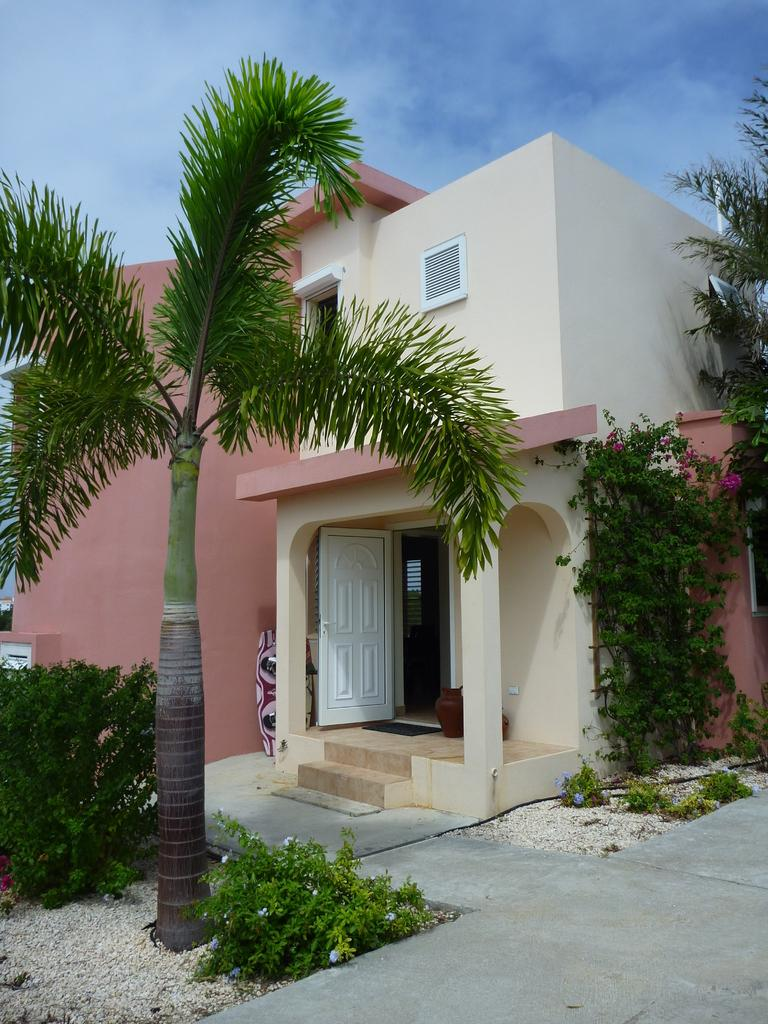What type of structure is visible in the image? There is a building in the image. What architectural features can be seen on the building? The building has pillars, windows, and doors. What is located in front of the building? There are plants and trees in front of the building. What can be seen at the top of the image? The sky is visible at the top of the image. What type of beef is being served at the building in the image? There is no beef or any indication of food being served in the image; it only shows a building with architectural features and surrounding plants and trees. 